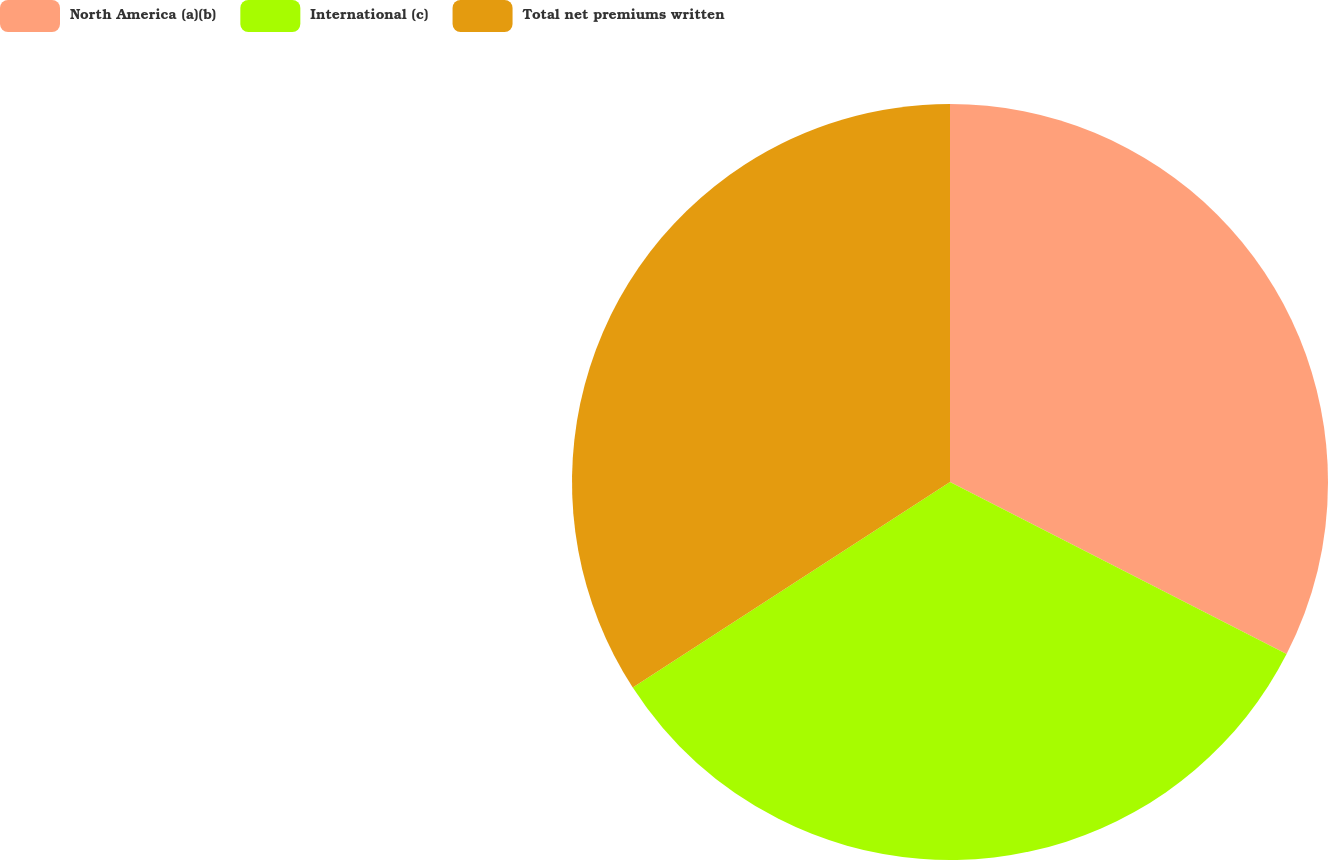Convert chart. <chart><loc_0><loc_0><loc_500><loc_500><pie_chart><fcel>North America (a)(b)<fcel>International (c)<fcel>Total net premiums written<nl><fcel>32.52%<fcel>33.33%<fcel>34.15%<nl></chart> 